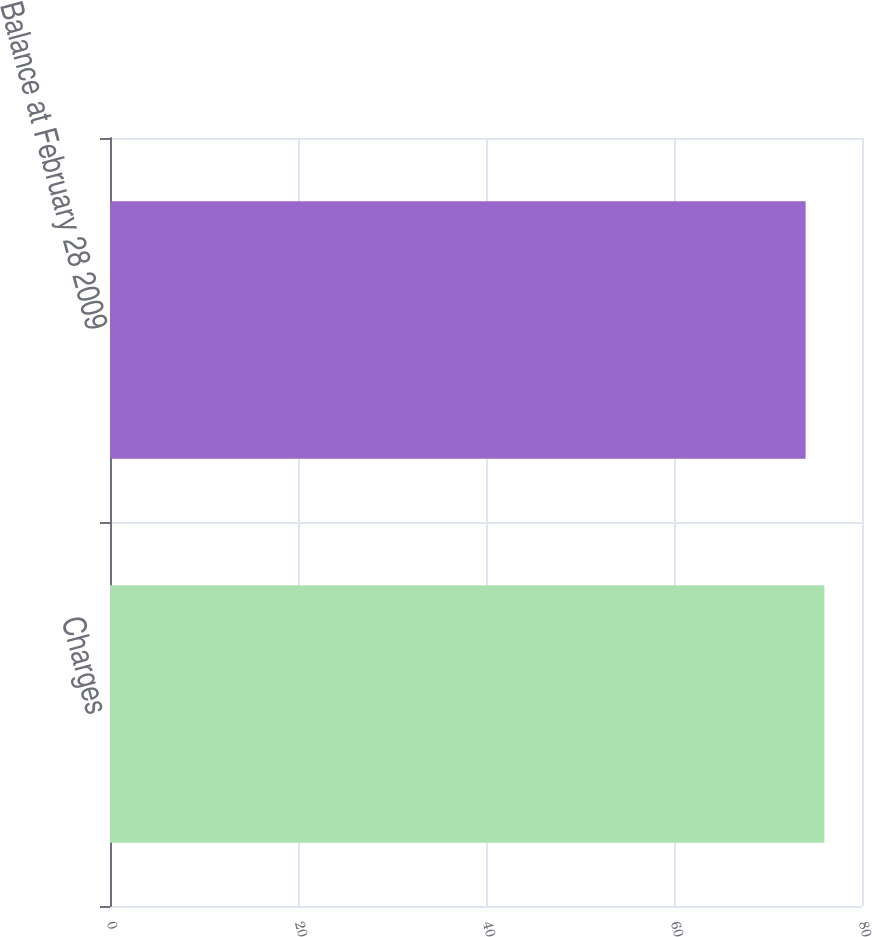<chart> <loc_0><loc_0><loc_500><loc_500><bar_chart><fcel>Charges<fcel>Balance at February 28 2009<nl><fcel>76<fcel>74<nl></chart> 